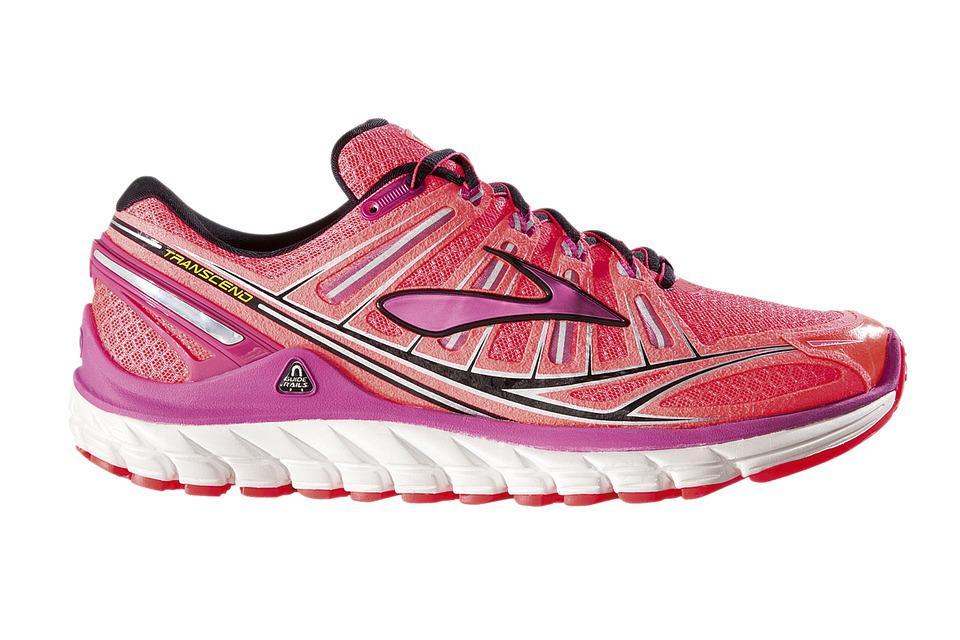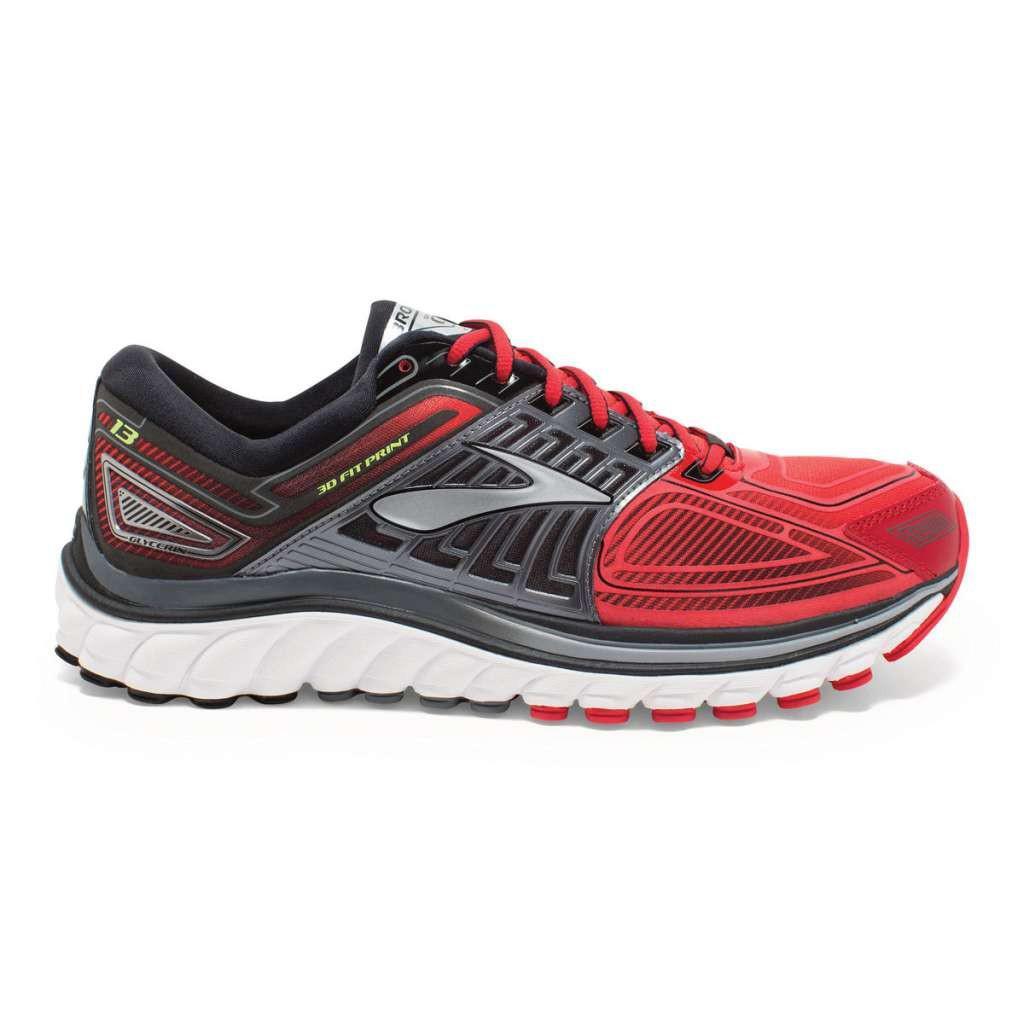The first image is the image on the left, the second image is the image on the right. Evaluate the accuracy of this statement regarding the images: "The images show a total of two sneakers, both facing right.". Is it true? Answer yes or no. Yes. 